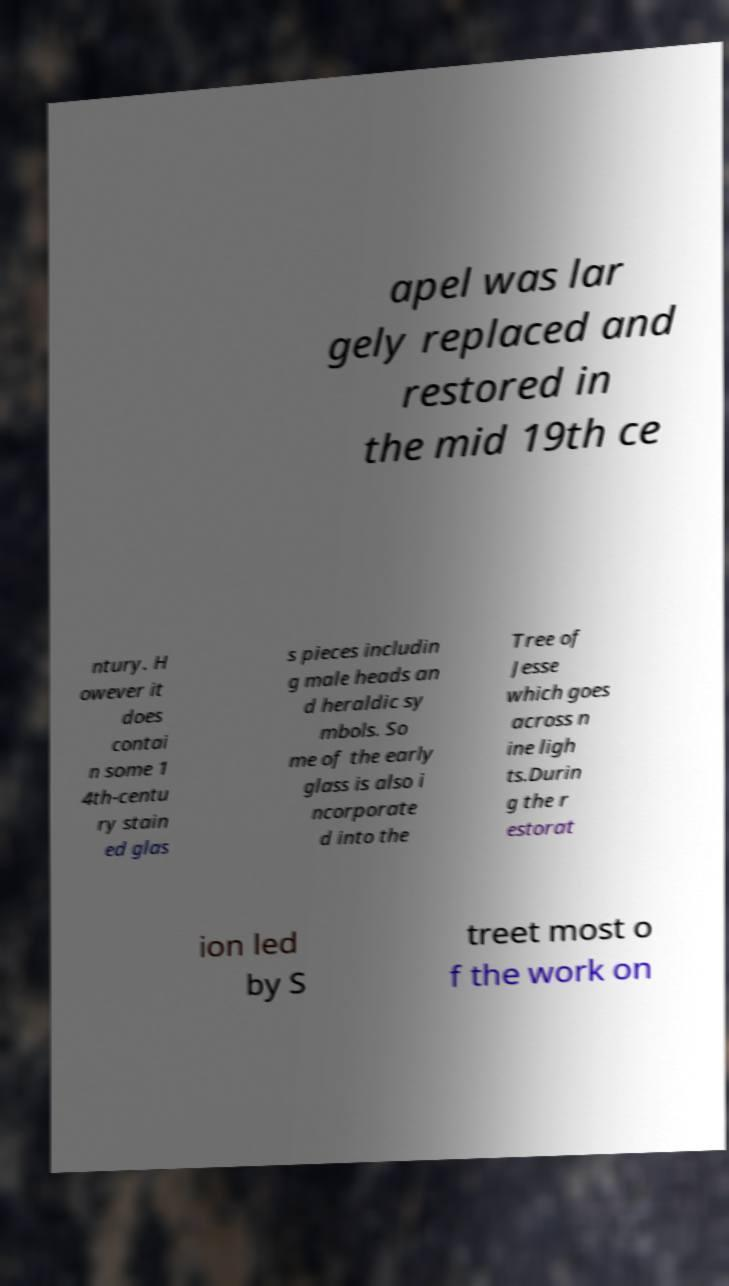Could you assist in decoding the text presented in this image and type it out clearly? apel was lar gely replaced and restored in the mid 19th ce ntury. H owever it does contai n some 1 4th-centu ry stain ed glas s pieces includin g male heads an d heraldic sy mbols. So me of the early glass is also i ncorporate d into the Tree of Jesse which goes across n ine ligh ts.Durin g the r estorat ion led by S treet most o f the work on 